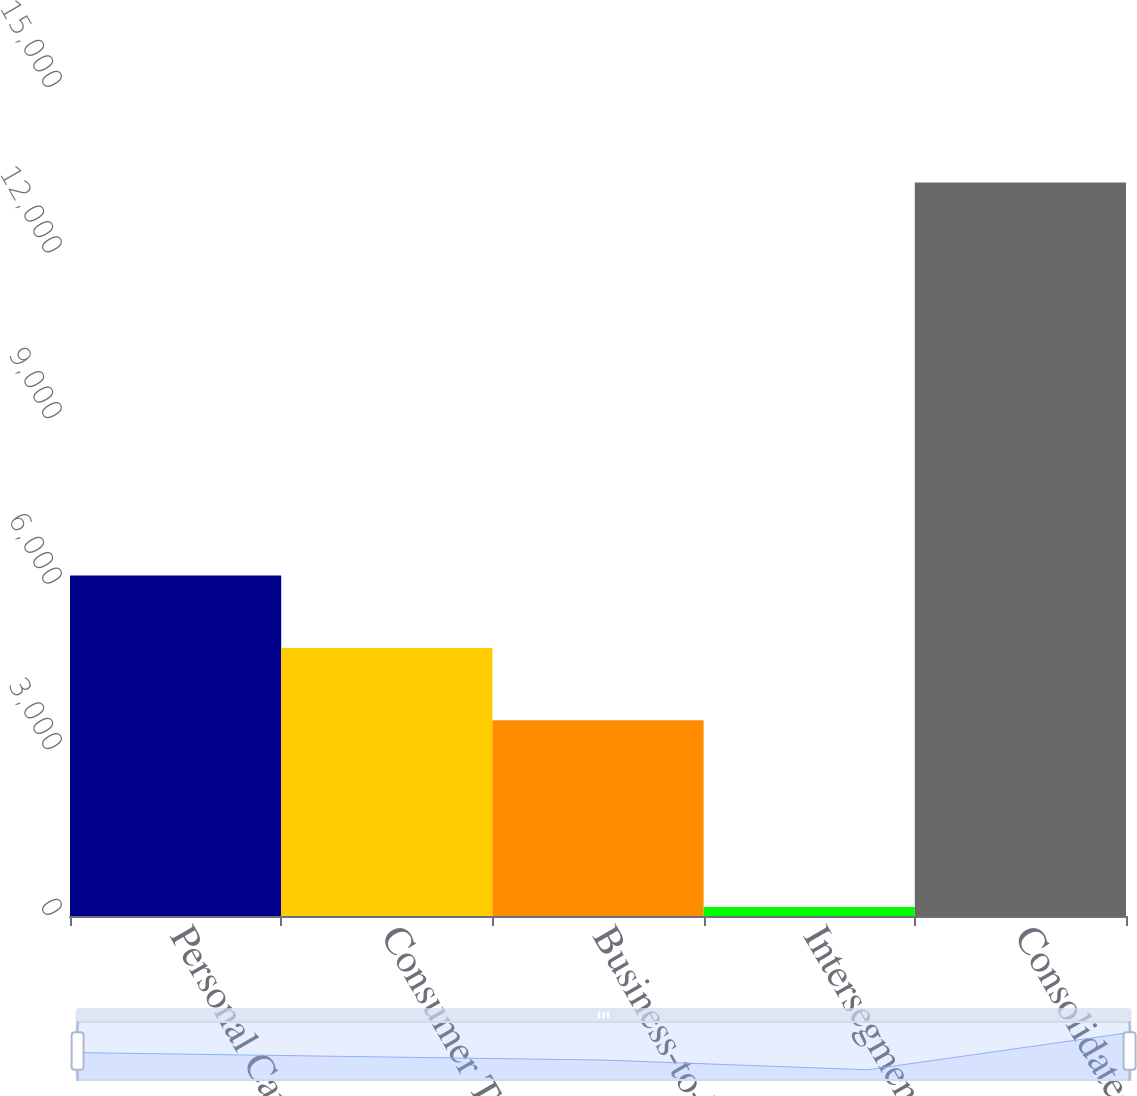Convert chart to OTSL. <chart><loc_0><loc_0><loc_500><loc_500><bar_chart><fcel>Personal Care<fcel>Consumer Tissue<fcel>Business-to-Business<fcel>Intersegment sales<fcel>Consolidated<nl><fcel>6169.82<fcel>4857.21<fcel>3544.6<fcel>161.5<fcel>13287.6<nl></chart> 